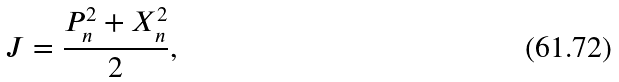<formula> <loc_0><loc_0><loc_500><loc_500>J = \frac { P _ { n } ^ { 2 } + X _ { n } ^ { 2 } } { 2 } ,</formula> 